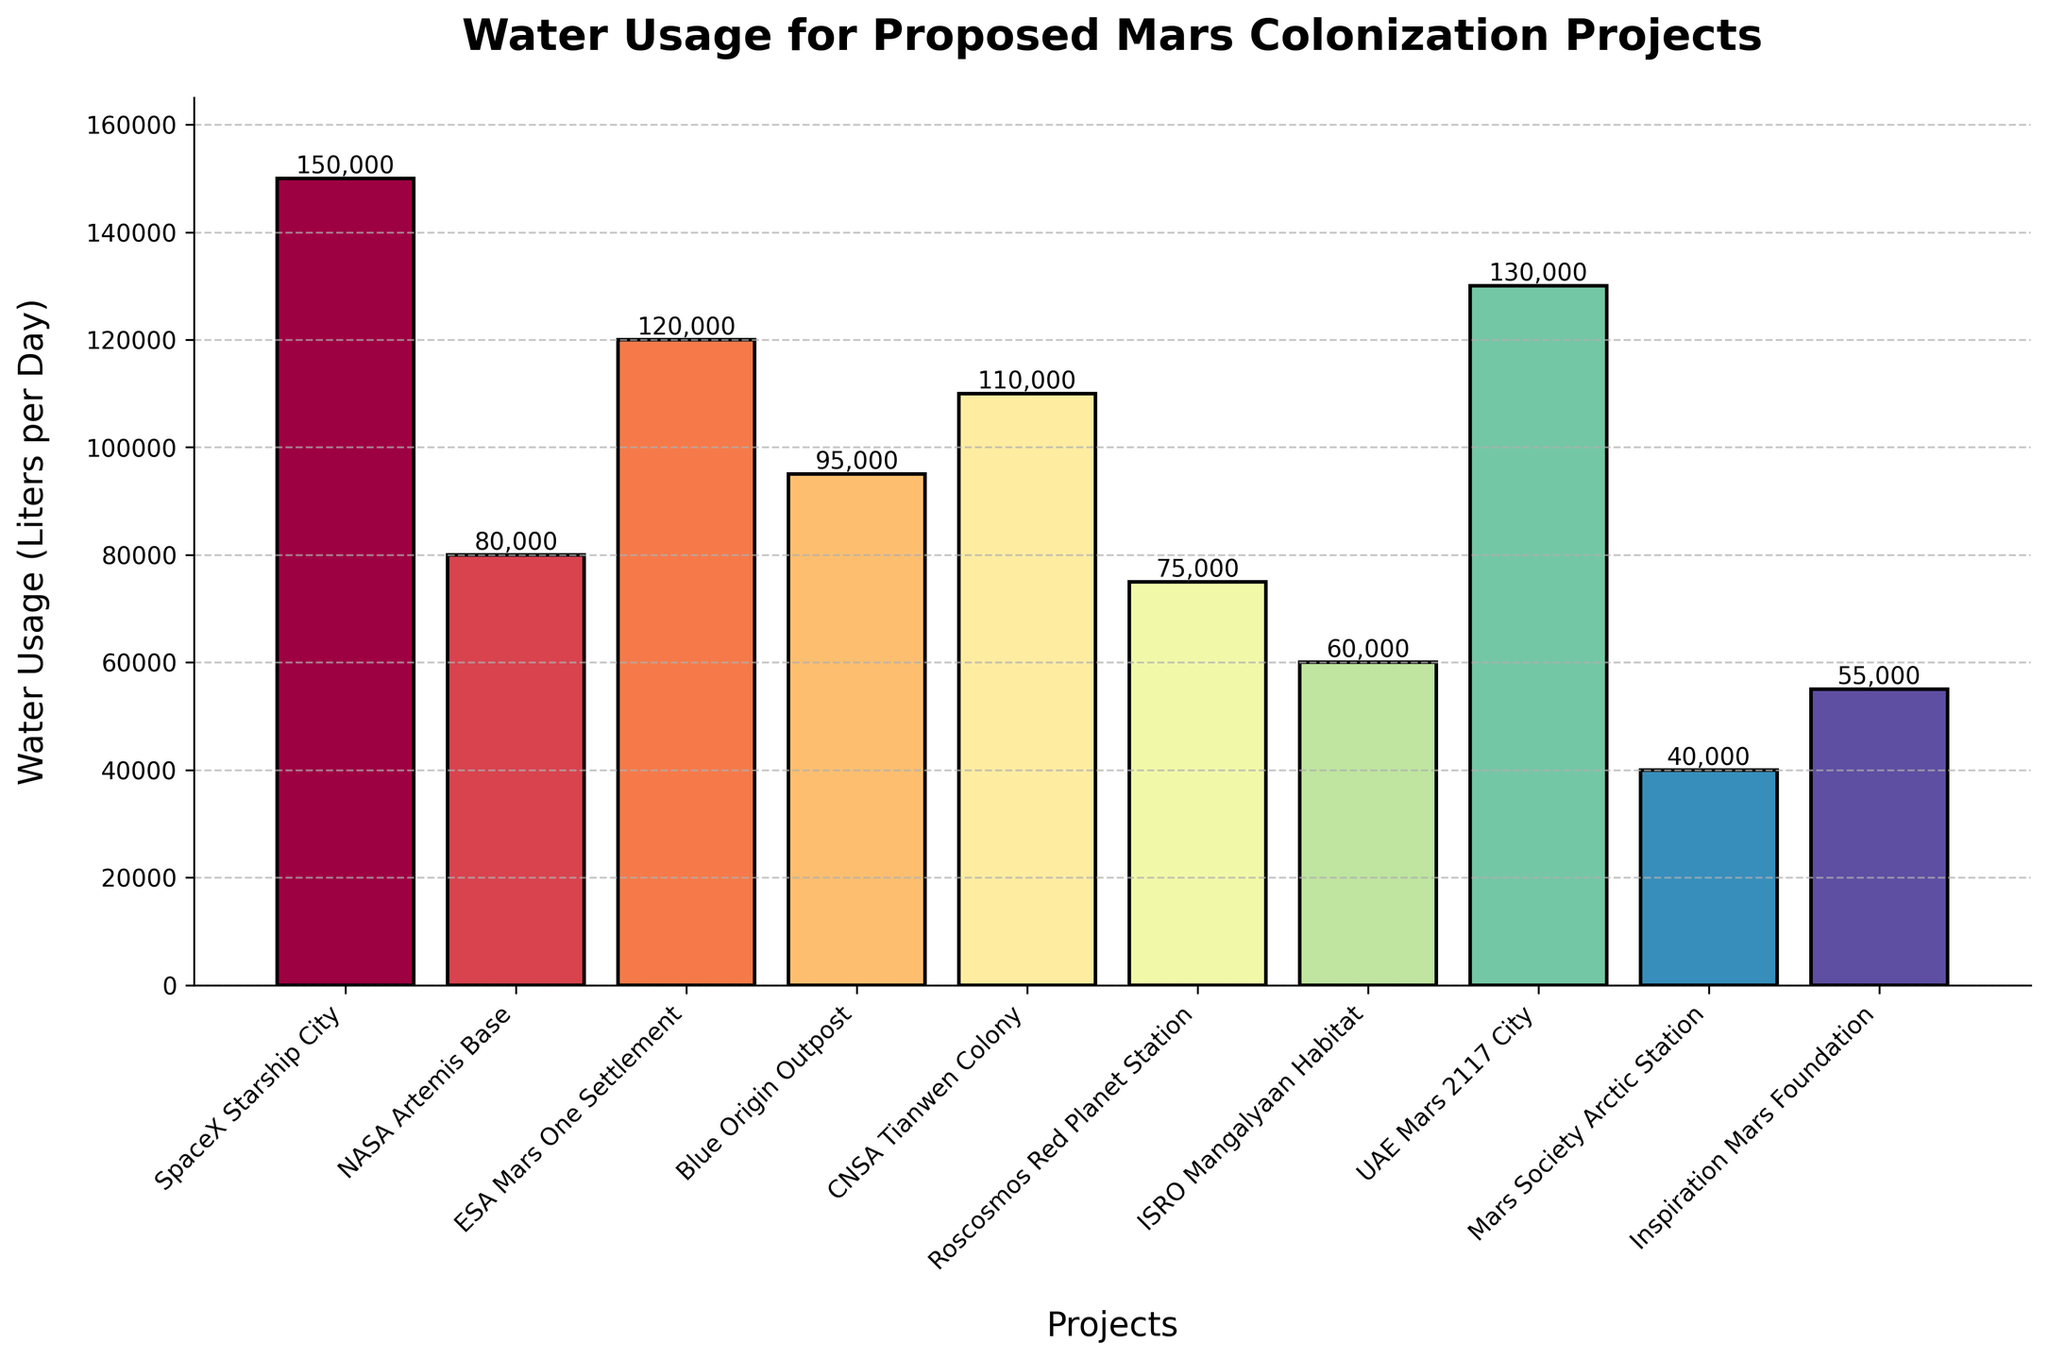Which project has the highest water usage? By looking at the heights of the bars and the text annotations showing water usage values, the highest bar corresponds to "SpaceX Starship City" with 150,000 liters per day.
Answer: SpaceX Starship City Which project uses less water, ESA Mars One Settlement or Blue Origin Outpost? Compare the heights and the annotated values of the bars for both projects. ESA Mars One Settlement uses 120,000 liters per day, whereas Blue Origin Outpost uses 95,000 liters per day.
Answer: Blue Origin Outpost What is the difference in water usage between the SpaceX Starship City and the Inspiration Mars Foundation? Reference the annotated water usage values for both projects: SpaceX Starship City uses 150,000 liters per day, and Inspiration Mars Foundation uses 55,000 liters per day. The difference is 150,000 - 55,000 = 95,000 liters per day.
Answer: 95,000 liters per day How many projects use more than 100,000 liters of water per day? Identify and count the bars with annotated values greater than 100,000 liters per day. There are four such projects: SpaceX Starship City, ESA Mars One Settlement, CNSA Tianwen Colony, and UAE Mars 2117 City.
Answer: Four projects What is the average water usage of all the projects combined? Sum the water usage of all projects and divide by the number of projects. The sum is 150,000 + 80,000 + 120,000 + 95,000 + 110,000 + 75,000 + 60,000 + 130,000 + 40,000 + 55,000 = 915,000 liters per day. There are 10 projects, so the average is 915,000 / 10 = 91,500 liters per day.
Answer: 91,500 liters per day Which project has the lowest water usage? By looking at the heights of the bars and the text annotations showing water usage values, the lowest bar corresponds to Mars Society Arctic Station with 40,000 liters per day.
Answer: Mars Society Arctic Station 